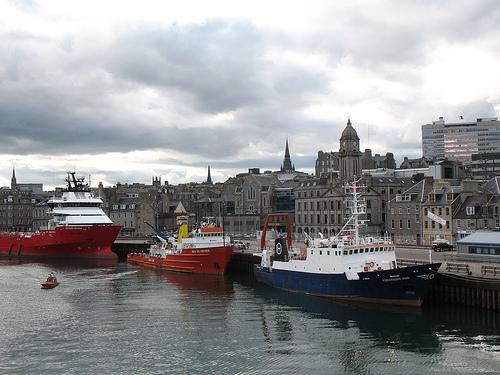Describe the body of water present in the image and the elements within it. There's dark blue water with some ripples and boats floating on it, including a jet ski. Identify the colors of the three prominent boats and where they are situated in the image. Red boat on the left, yellow and white boat in the middle, and blue and white boat on the right. In a casual tone, tell me what the person on the boat is doing. There's a dude chillin' on the boat, just enjoying the ride. What kind of vehicle is parked on the pavement? There's a small vehicle parked on the pavement near the road. Mention a specific architectural feature of a building in the image. There's a pointed dome on one of the buildings in the scene. Estimate the image quality by describing its sharpness, colors, and clarity. The image presents good quality with sharp details, vibrant colors, and clear distinction between the elements. Express the sentiment or mood conveyed by the image. The image evokes a tranquil and peaceful feeling, with boats calmly floating on the water and a serene backdrop of buildings and sky. Count the number of small windows on the buildings and state what they have in common. There are numerous small windows on the buildings, and they all have a similar rectangular shape. What is the interaction between the main objects in the image? The boats are floating near each other on the water and the buildings are providing a backdrop to this scene. There isn't any direct interaction between the objects. How many rows of tall windows can you see on the buildings? There are multiple rows of tall windows on the buildings in the image. 